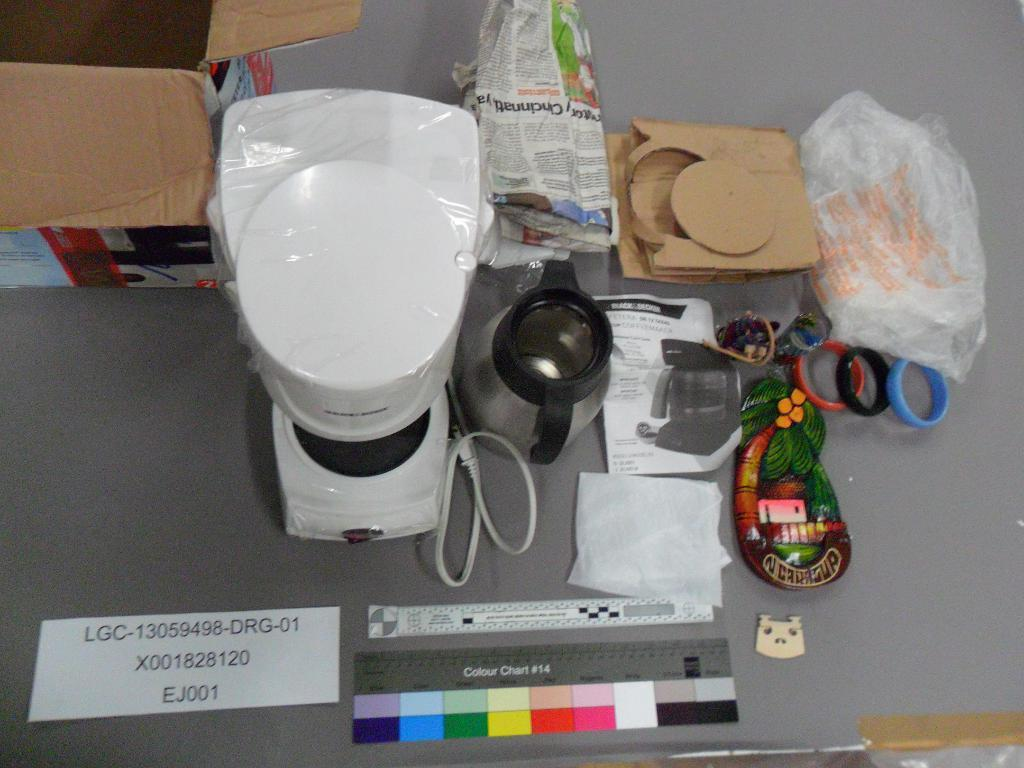<image>
Share a concise interpretation of the image provided. A paper sign that says EJ001 on it sits near a coffee maker. 